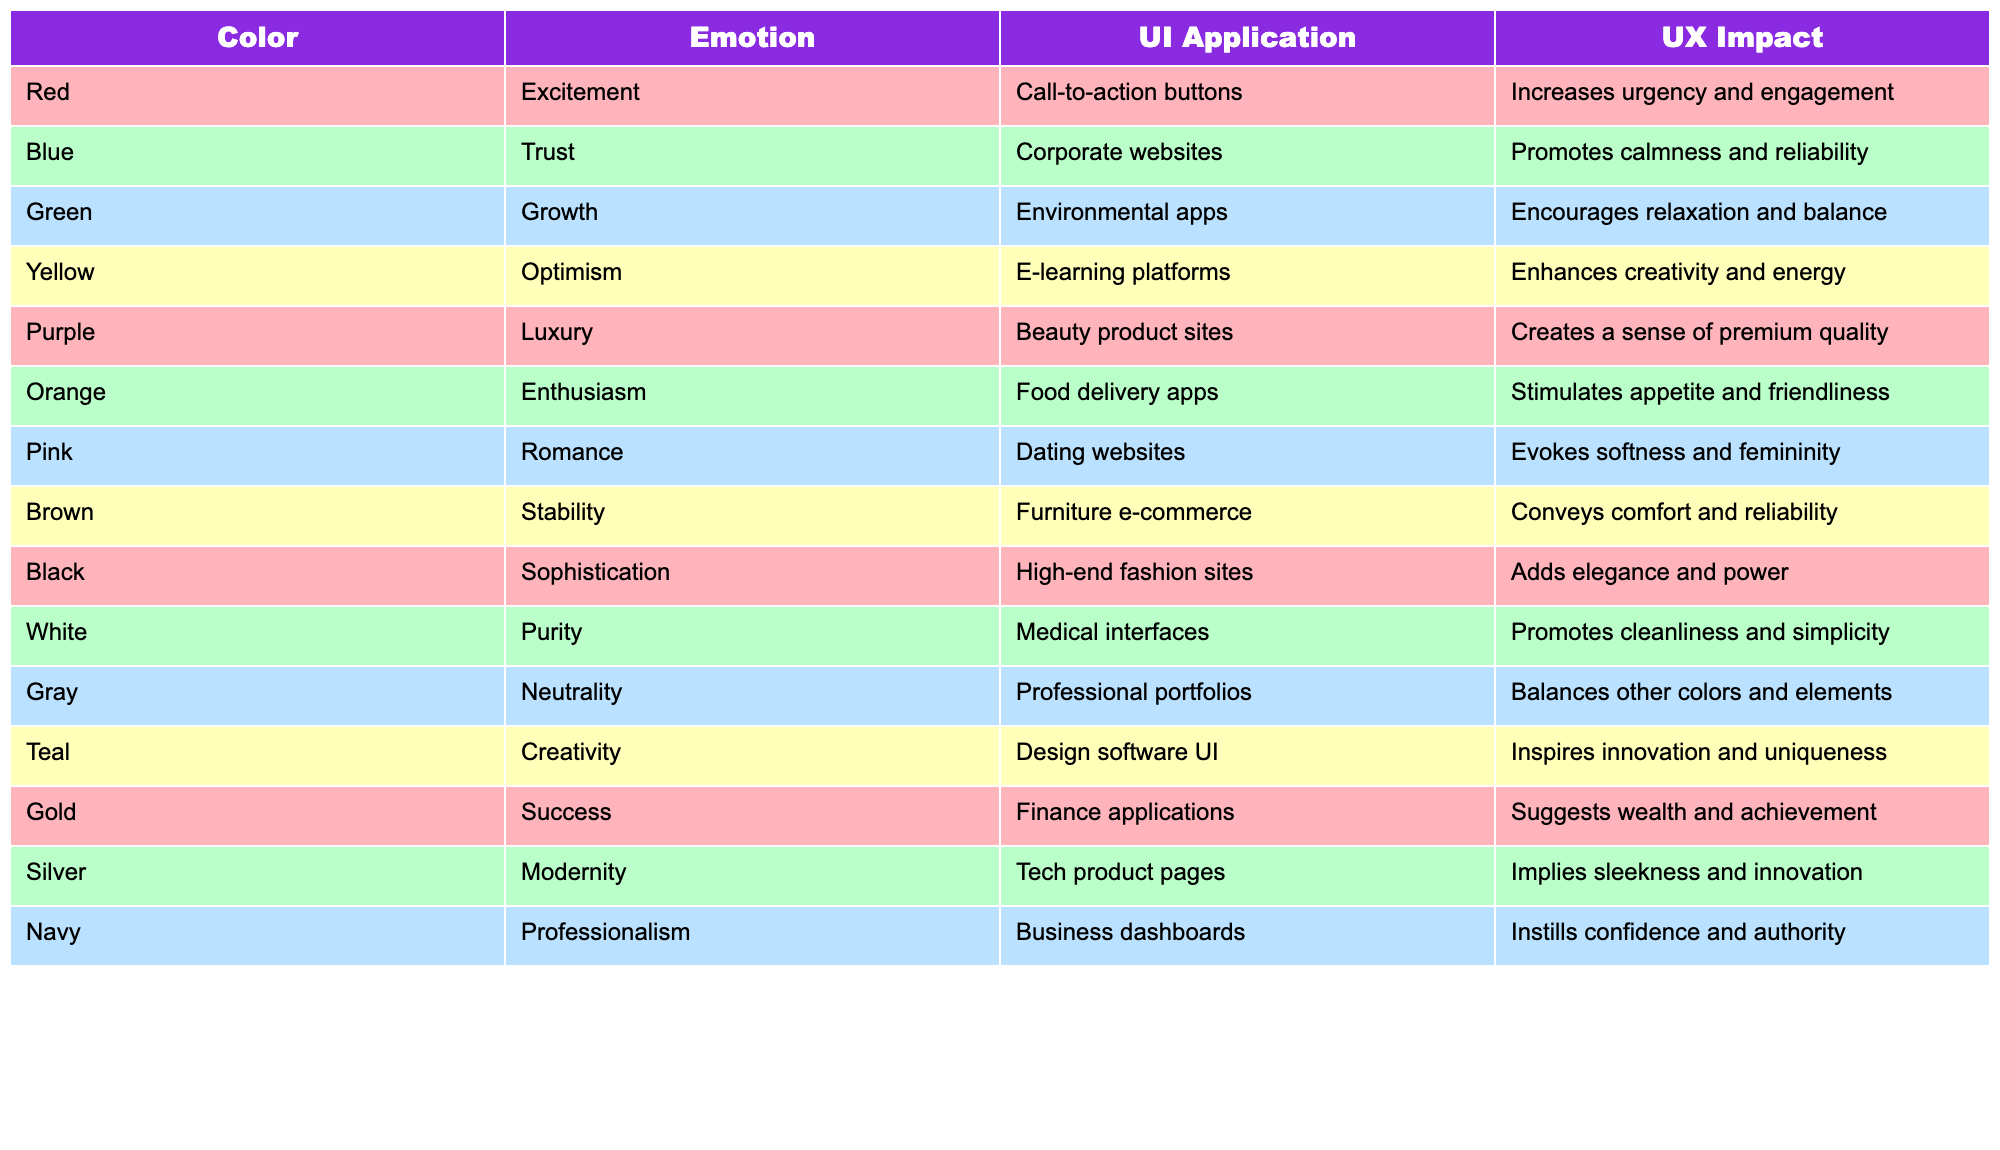What emotion is associated with the color green? The table states that the color green is associated with the emotion of growth.
Answer: Growth Which color is used for call-to-action buttons? According to the table, the color red is used for call-to-action buttons.
Answer: Red Is purple associated with feelings of warmth and friendliness? The table shows that purple is linked to luxury, not warmth and friendliness, which are associated with orange.
Answer: No What is the average emotion score for the following colors: blue, yellow, and pink? The emotions are: blue (trust), yellow (optimism), and pink (romance). There are three unique emotions here. Since there's no numerical score mentioned, we don't average them, but you can conclude they each represent a different positive emotional state.
Answer: Cannot be averaged, they are unique emotions Which color promotes calmness and reliability? The table indicates that blue promotes calmness and reliability.
Answer: Blue What UI application is associated with the color black? The table specifies that black is used for high-end fashion sites in UI applications.
Answer: High-end fashion sites Does yellow effectively stimulate energy in users? Yes, the table states that yellow enhances creativity and energy, showing it can be stimulating to users.
Answer: Yes What two colors are associated with success in the finance applications? The table indicates that gold suggests wealth and achievement, while there is no other color associated with success for finance applications.
Answer: Gold only Which two colors evoke romance and femininity in web design? Based on the table, pink is linked to romance and evokes softness and femininity, while no other color in the table has these specific attributes.
Answer: Pink only Does the color gray help balance other colors in design? Yes, the table indicates that gray balances other colors and elements, supporting its role in a cohesive design.
Answer: Yes 